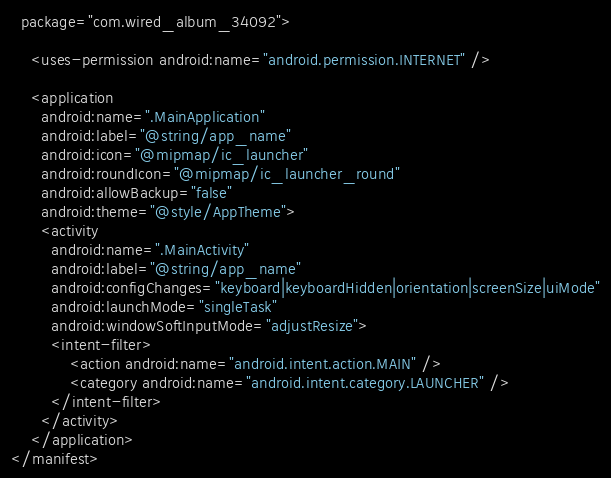<code> <loc_0><loc_0><loc_500><loc_500><_XML_>  package="com.wired_album_34092">

    <uses-permission android:name="android.permission.INTERNET" />

    <application
      android:name=".MainApplication"
      android:label="@string/app_name"
      android:icon="@mipmap/ic_launcher"
      android:roundIcon="@mipmap/ic_launcher_round"
      android:allowBackup="false"
      android:theme="@style/AppTheme">
      <activity
        android:name=".MainActivity"
        android:label="@string/app_name"
        android:configChanges="keyboard|keyboardHidden|orientation|screenSize|uiMode"
        android:launchMode="singleTask"
        android:windowSoftInputMode="adjustResize">
        <intent-filter>
            <action android:name="android.intent.action.MAIN" />
            <category android:name="android.intent.category.LAUNCHER" />
        </intent-filter>
      </activity>
    </application>
</manifest>
</code> 